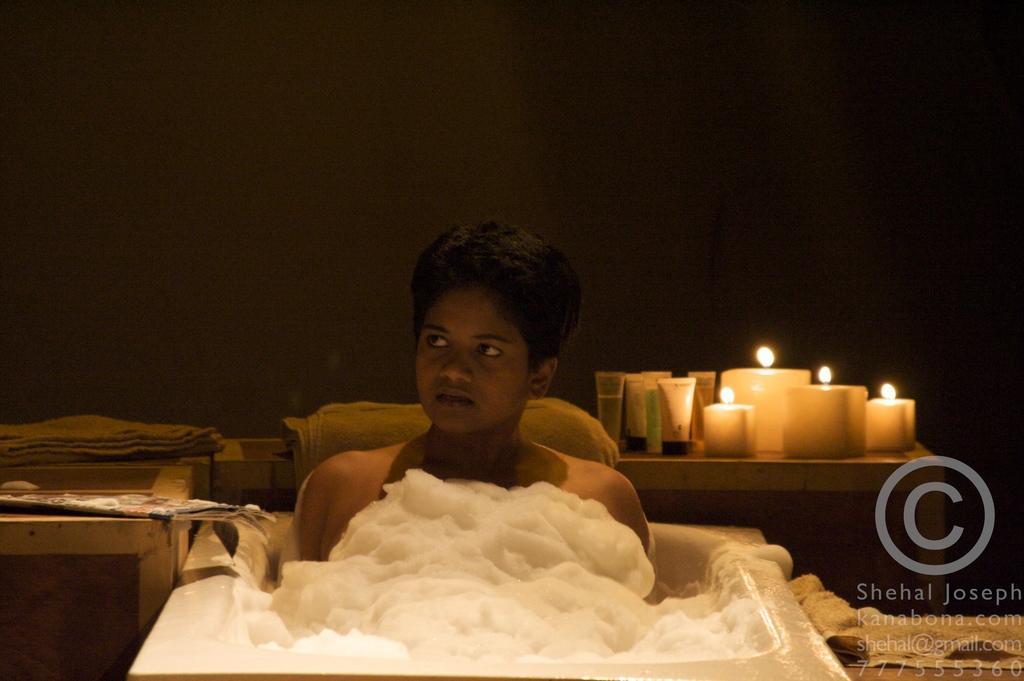In one or two sentences, can you explain what this image depicts? In this image there is a person in a bath tub, and there are cream tubes, candles, towels on the tables and there is a watermark on the image. 